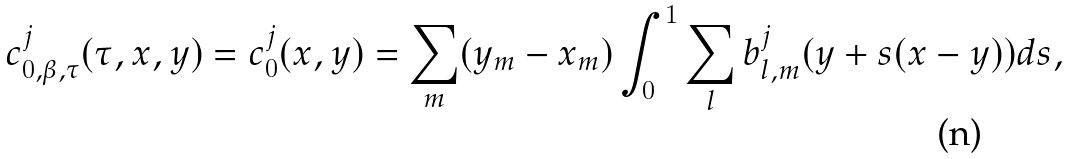<formula> <loc_0><loc_0><loc_500><loc_500>c ^ { j } _ { 0 , \beta , \tau } ( \tau , x , y ) = c ^ { j } _ { 0 } ( x , y ) = \sum _ { m } ( y _ { m } - x _ { m } ) \int _ { 0 } ^ { 1 } \sum _ { l } b ^ { j } _ { l , m } ( y + s ( x - y ) ) d s ,</formula> 